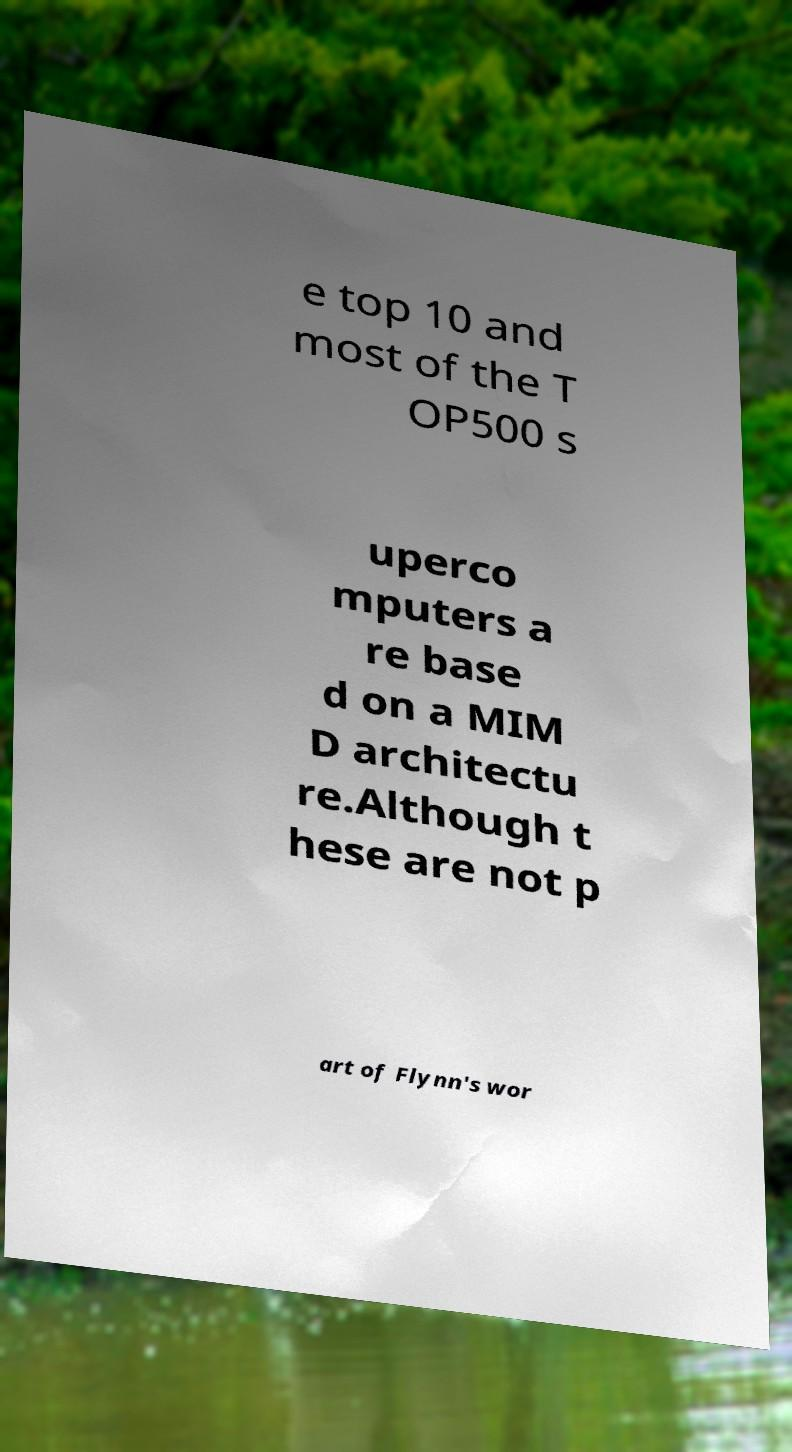Can you accurately transcribe the text from the provided image for me? e top 10 and most of the T OP500 s uperco mputers a re base d on a MIM D architectu re.Although t hese are not p art of Flynn's wor 